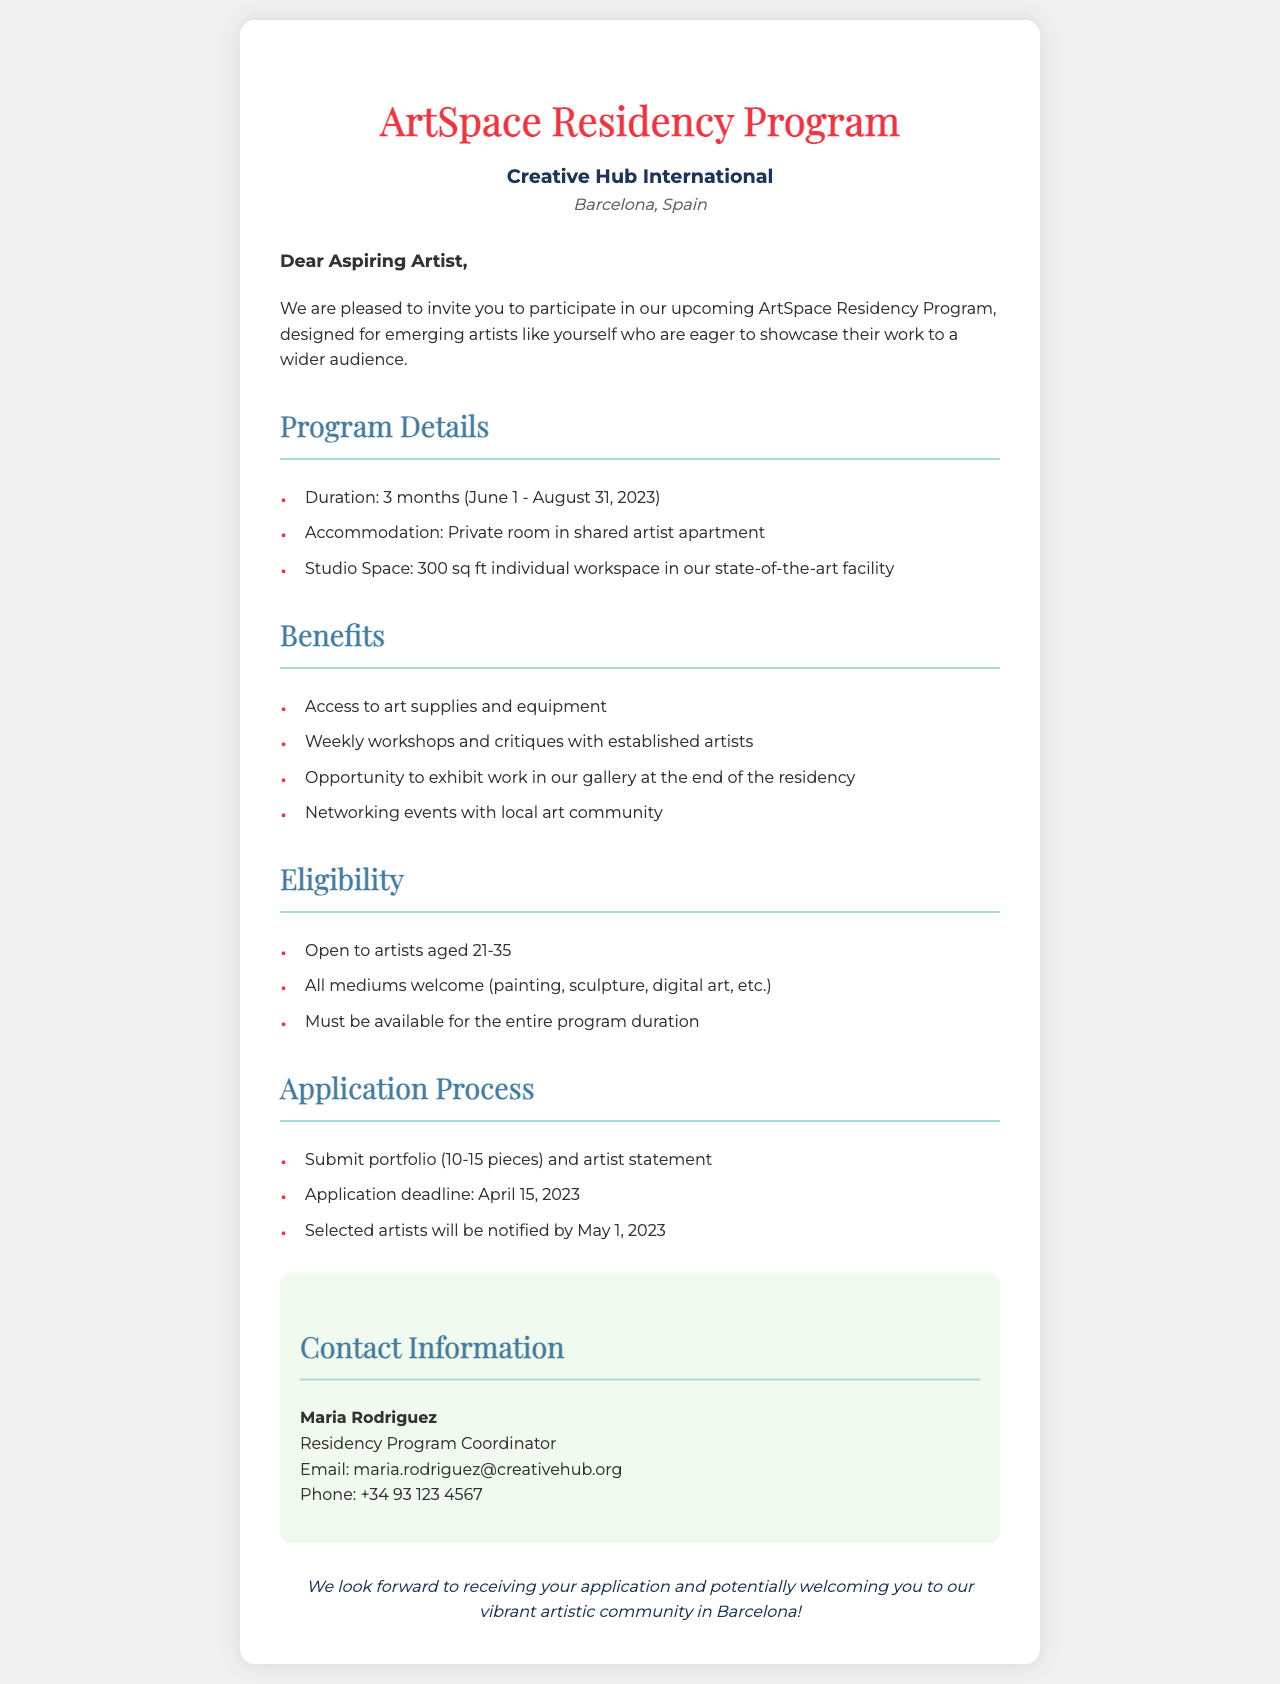What is the duration of the residency program? The duration of the residency program is stated in the program details section, which indicates it is 3 months from June 1 to August 31, 2023.
Answer: 3 months (June 1 - August 31, 2023) What type of accommodation is provided? The accommodation type is specified in the program details section, which describes it as a private room in a shared artist apartment.
Answer: Private room in shared artist apartment How large is the studio space? The size of the studio space is mentioned in the program details section, indicating it is 300 sq ft.
Answer: 300 sq ft Who is the contact person for the residency program? The document names the contact person for the residency program in the contact information section as Maria Rodriguez.
Answer: Maria Rodriguez What is the application deadline? The application deadline is specified in the application process section of the document as April 15, 2023.
Answer: April 15, 2023 What is the age range for eligibility? The eligibility criteria outlines the age range, stating it is open to artists aged 21-35.
Answer: 21-35 What is the opportunity provided at the end of the residency? The benefits section notes that there is an opportunity to exhibit work in the gallery at the end of the residency.
Answer: Exhibit work in our gallery What should be submitted as part of the application? The application process section lists the requirement to submit a portfolio and artist statement.
Answer: Portfolio (10-15 pieces) and artist statement What city is the residency program located in? The location of the residency program is mentioned at the top of the document, indicating it is in Barcelona, Spain.
Answer: Barcelona, Spain 